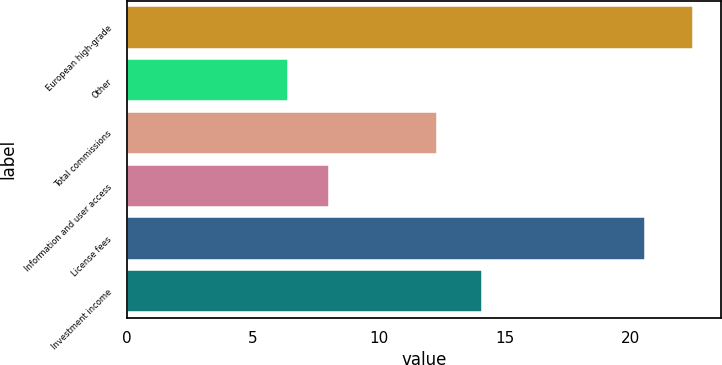Convert chart. <chart><loc_0><loc_0><loc_500><loc_500><bar_chart><fcel>European high-grade<fcel>Other<fcel>Total commissions<fcel>Information and user access<fcel>License fees<fcel>Investment income<nl><fcel>22.5<fcel>6.4<fcel>12.3<fcel>8.01<fcel>20.6<fcel>14.1<nl></chart> 